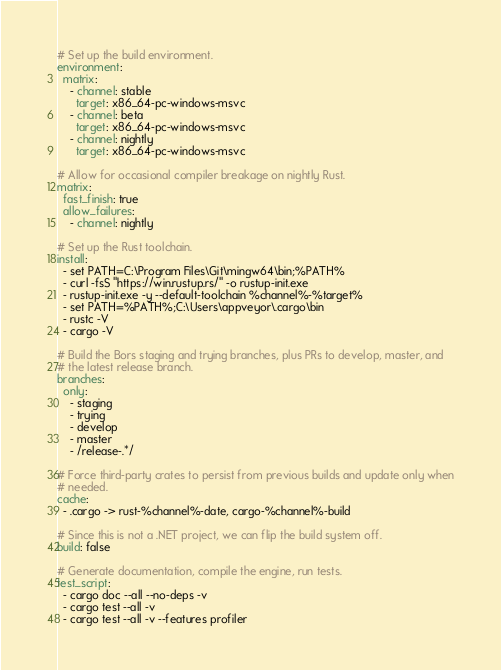<code> <loc_0><loc_0><loc_500><loc_500><_YAML_># Set up the build environment.
environment:
  matrix:
    - channel: stable
      target: x86_64-pc-windows-msvc
    - channel: beta
      target: x86_64-pc-windows-msvc
    - channel: nightly
      target: x86_64-pc-windows-msvc

# Allow for occasional compiler breakage on nightly Rust.
matrix:
  fast_finish: true
  allow_failures:
    - channel: nightly

# Set up the Rust toolchain.
install:
  - set PATH=C:\Program Files\Git\mingw64\bin;%PATH%
  - curl -fsS "https://win.rustup.rs/" -o rustup-init.exe
  - rustup-init.exe -y --default-toolchain %channel%-%target%
  - set PATH=%PATH%;C:\Users\appveyor\.cargo\bin
  - rustc -V
  - cargo -V

# Build the Bors staging and trying branches, plus PRs to develop, master, and
# the latest release branch.
branches:
  only:
    - staging
    - trying
    - develop
    - master
    - /release-.*/

# Force third-party crates to persist from previous builds and update only when
# needed.
cache:
  - .cargo -> rust-%channel%-date, cargo-%channel%-build

# Since this is not a .NET project, we can flip the build system off.
build: false

# Generate documentation, compile the engine, run tests.
test_script:
  - cargo doc --all --no-deps -v
  - cargo test --all -v
  - cargo test --all -v --features profiler
</code> 